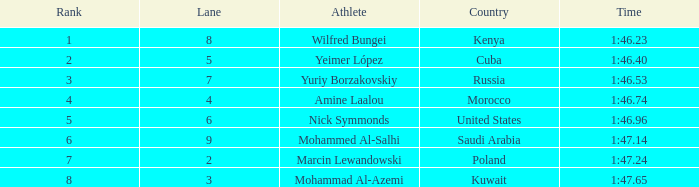65 and in lane 3 or bigger? None. 